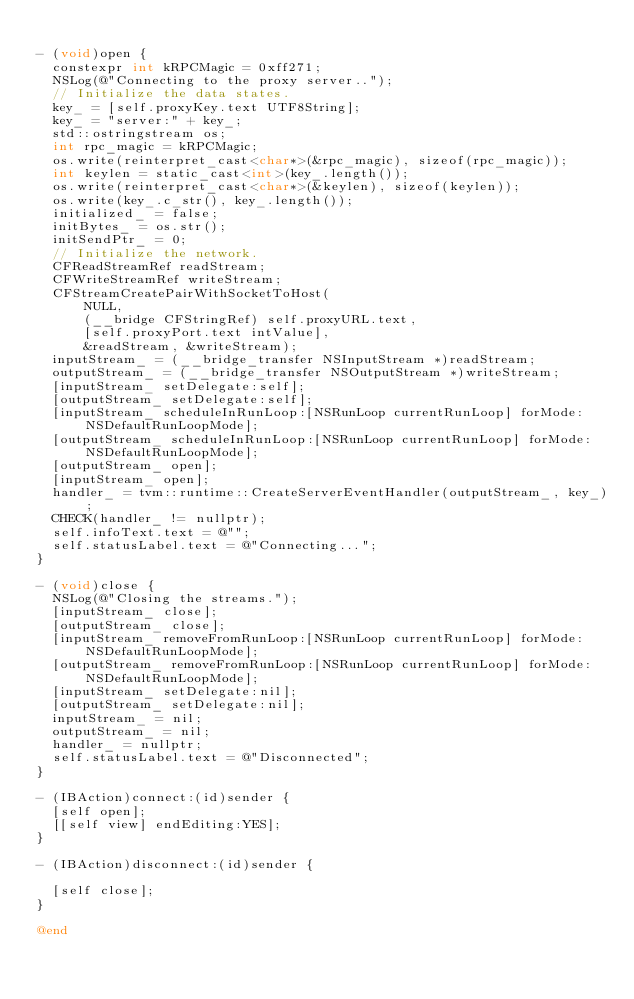Convert code to text. <code><loc_0><loc_0><loc_500><loc_500><_ObjectiveC_>
- (void)open {
  constexpr int kRPCMagic = 0xff271;
  NSLog(@"Connecting to the proxy server..");
  // Initialize the data states.
  key_ = [self.proxyKey.text UTF8String];
  key_ = "server:" + key_;
  std::ostringstream os;
  int rpc_magic = kRPCMagic;
  os.write(reinterpret_cast<char*>(&rpc_magic), sizeof(rpc_magic));
  int keylen = static_cast<int>(key_.length());
  os.write(reinterpret_cast<char*>(&keylen), sizeof(keylen));
  os.write(key_.c_str(), key_.length());
  initialized_ = false;
  initBytes_ = os.str();
  initSendPtr_ = 0;
  // Initialize the network.
  CFReadStreamRef readStream;
  CFWriteStreamRef writeStream;
  CFStreamCreatePairWithSocketToHost(
      NULL,
      (__bridge CFStringRef) self.proxyURL.text,
      [self.proxyPort.text intValue],
      &readStream, &writeStream);
  inputStream_ = (__bridge_transfer NSInputStream *)readStream;
  outputStream_ = (__bridge_transfer NSOutputStream *)writeStream;
  [inputStream_ setDelegate:self];
  [outputStream_ setDelegate:self];
  [inputStream_ scheduleInRunLoop:[NSRunLoop currentRunLoop] forMode:NSDefaultRunLoopMode];
  [outputStream_ scheduleInRunLoop:[NSRunLoop currentRunLoop] forMode:NSDefaultRunLoopMode];
  [outputStream_ open];
  [inputStream_ open];
  handler_ = tvm::runtime::CreateServerEventHandler(outputStream_, key_);
  CHECK(handler_ != nullptr);
  self.infoText.text = @"";
  self.statusLabel.text = @"Connecting...";
}

- (void)close {
  NSLog(@"Closing the streams.");
  [inputStream_ close];
  [outputStream_ close];
  [inputStream_ removeFromRunLoop:[NSRunLoop currentRunLoop] forMode:NSDefaultRunLoopMode];
  [outputStream_ removeFromRunLoop:[NSRunLoop currentRunLoop] forMode:NSDefaultRunLoopMode];
  [inputStream_ setDelegate:nil];
  [outputStream_ setDelegate:nil];
  inputStream_ = nil;
  outputStream_ = nil;
  handler_ = nullptr;
  self.statusLabel.text = @"Disconnected";
}

- (IBAction)connect:(id)sender {
  [self open];
  [[self view] endEditing:YES];
}

- (IBAction)disconnect:(id)sender {

  [self close];
}

@end
</code> 